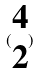Convert formula to latex. <formula><loc_0><loc_0><loc_500><loc_500>( \begin{matrix} 4 \\ 2 \end{matrix} )</formula> 